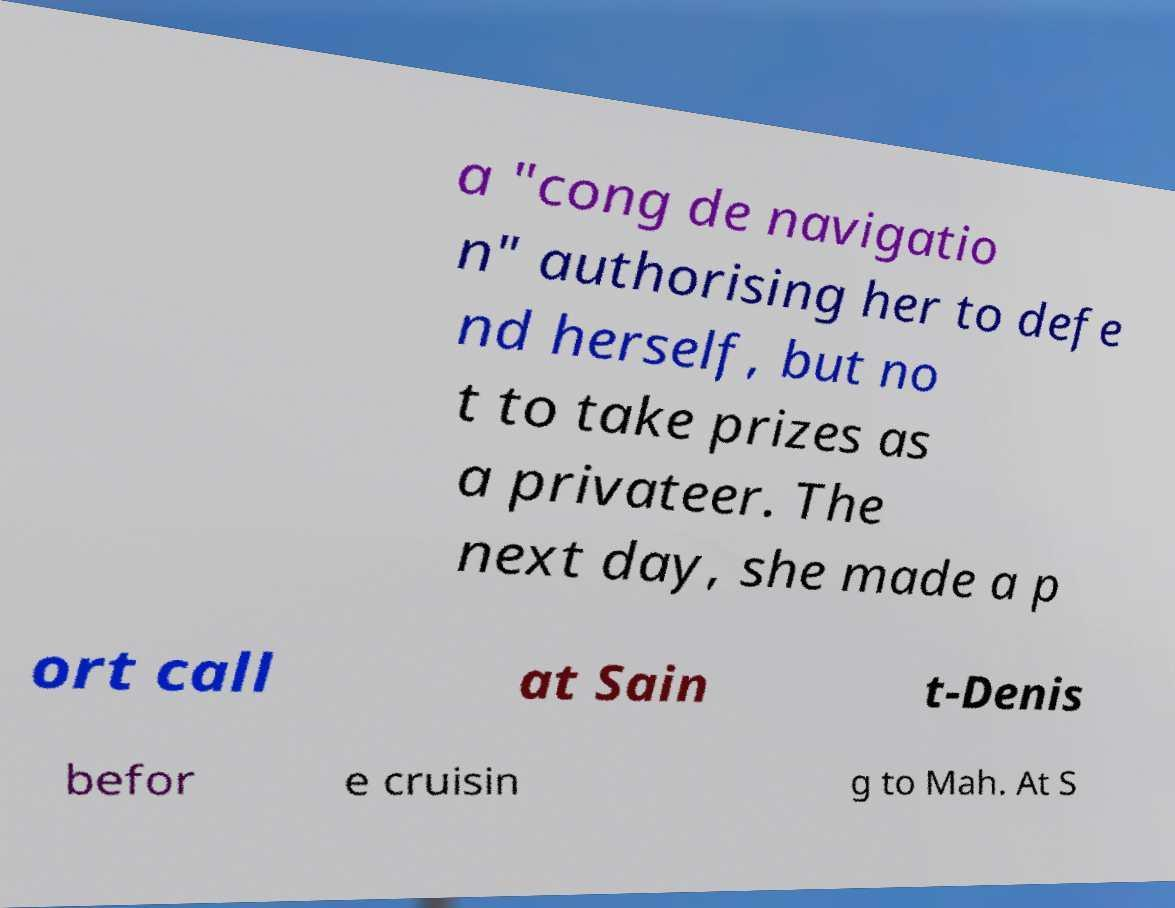For documentation purposes, I need the text within this image transcribed. Could you provide that? a "cong de navigatio n" authorising her to defe nd herself, but no t to take prizes as a privateer. The next day, she made a p ort call at Sain t-Denis befor e cruisin g to Mah. At S 